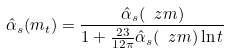<formula> <loc_0><loc_0><loc_500><loc_500>\hat { \alpha } _ { s } ( m _ { t } ) = \frac { \hat { \alpha } _ { s } ( \ z m ) } { 1 + \frac { 2 3 } { 1 2 \pi } { \hat { \alpha } _ { s } ( \ z m ) } \ln t }</formula> 